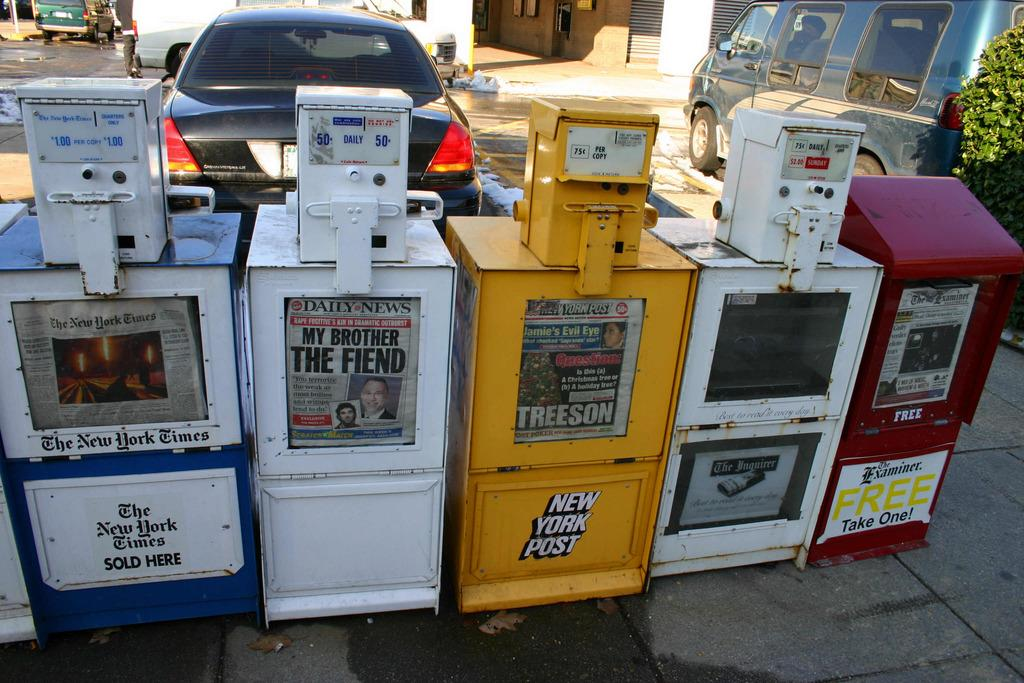What types of vehicles can be seen in the image? The image contains vehicles, but the specific types cannot be determined without more information. What else is present on the ground in the image? There are objects on the ground in the image, but their nature cannot be determined without more information. How many jellyfish are swimming in the image? There are no jellyfish present in the image; it features vehicles and objects on the ground. 